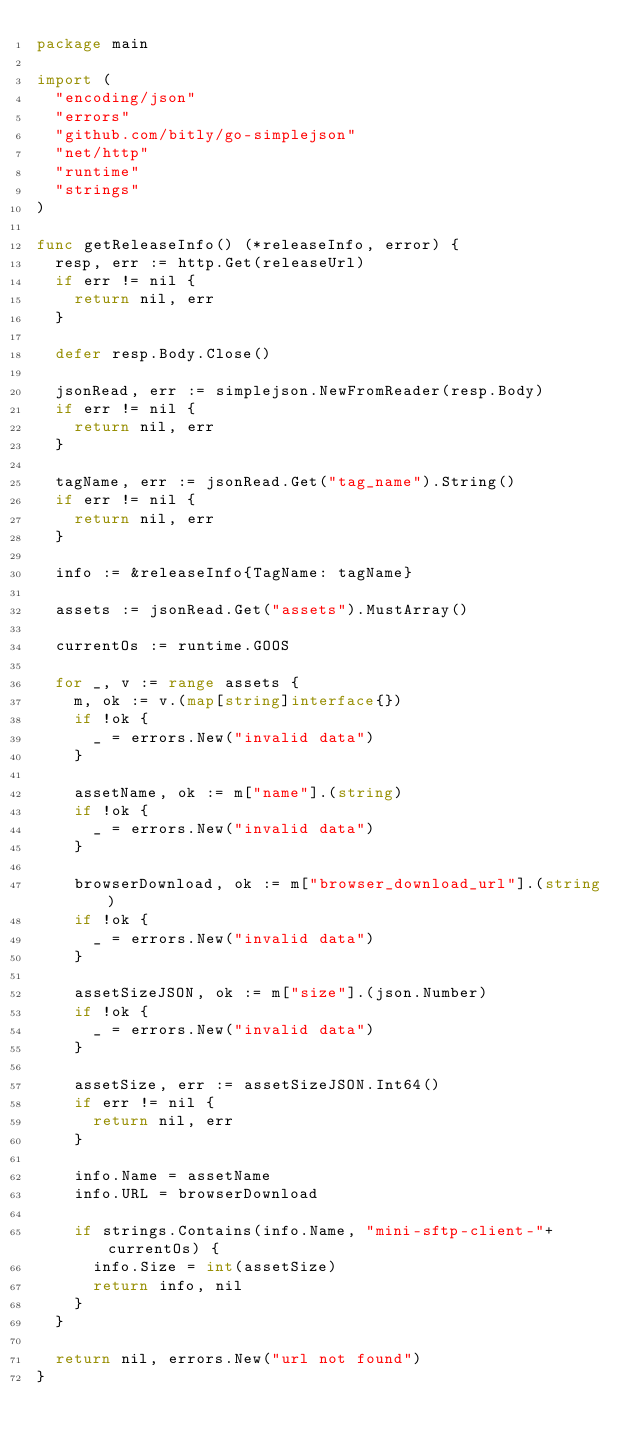Convert code to text. <code><loc_0><loc_0><loc_500><loc_500><_Go_>package main

import (
	"encoding/json"
	"errors"
	"github.com/bitly/go-simplejson"
	"net/http"
	"runtime"
	"strings"
)

func getReleaseInfo() (*releaseInfo, error) {
	resp, err := http.Get(releaseUrl)
	if err != nil {
		return nil, err
	}

	defer resp.Body.Close()

	jsonRead, err := simplejson.NewFromReader(resp.Body)
	if err != nil {
		return nil, err
	}

	tagName, err := jsonRead.Get("tag_name").String()
	if err != nil {
		return nil, err
	}

	info := &releaseInfo{TagName: tagName}

	assets := jsonRead.Get("assets").MustArray()

	currentOs := runtime.GOOS

	for _, v := range assets {
		m, ok := v.(map[string]interface{})
		if !ok {
			_ = errors.New("invalid data")
		}

		assetName, ok := m["name"].(string)
		if !ok {
			_ = errors.New("invalid data")
		}

		browserDownload, ok := m["browser_download_url"].(string)
		if !ok {
			_ = errors.New("invalid data")
		}

		assetSizeJSON, ok := m["size"].(json.Number)
		if !ok {
			_ = errors.New("invalid data")
		}

		assetSize, err := assetSizeJSON.Int64()
		if err != nil {
			return nil, err
		}

		info.Name = assetName
		info.URL = browserDownload

		if strings.Contains(info.Name, "mini-sftp-client-"+currentOs) {
			info.Size = int(assetSize)
			return info, nil
		}
	}

	return nil, errors.New("url not found")
}
</code> 